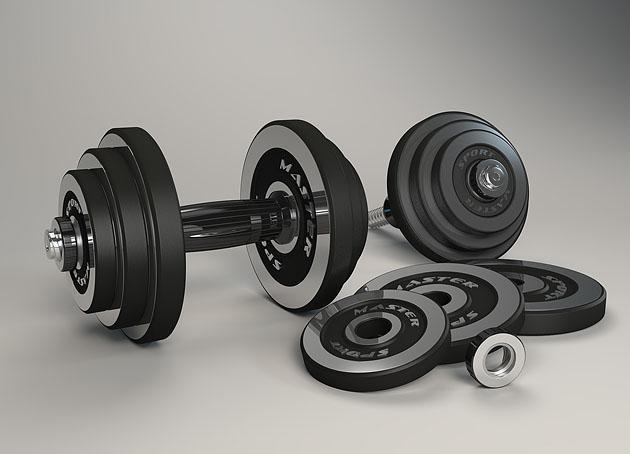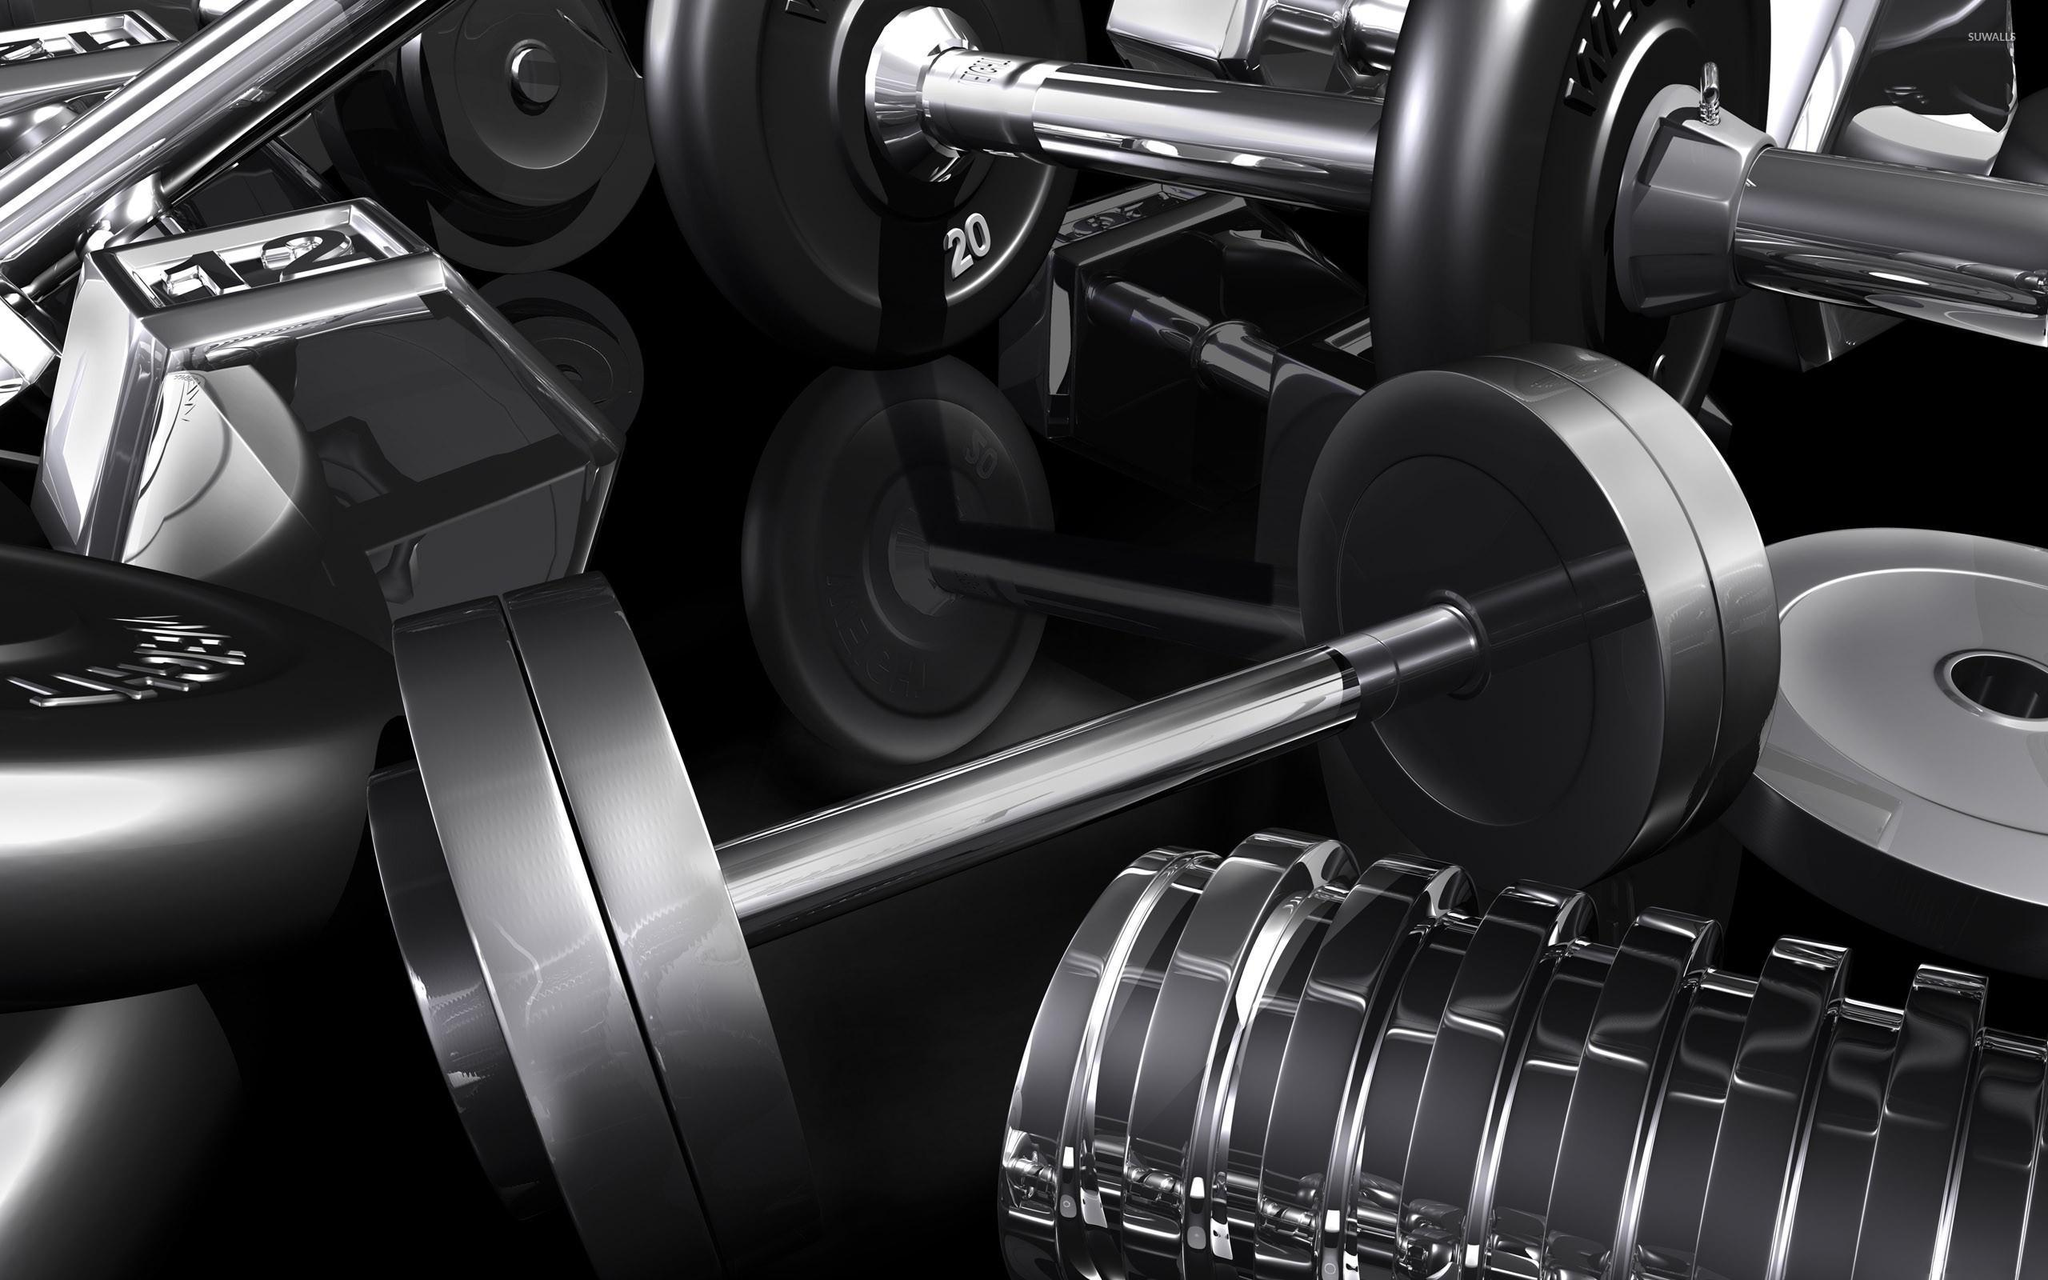The first image is the image on the left, the second image is the image on the right. Examine the images to the left and right. Is the description "One image shows a pair of small, matched dumbbells, with the end of one angled onto the bar of the other." accurate? Answer yes or no. No. 